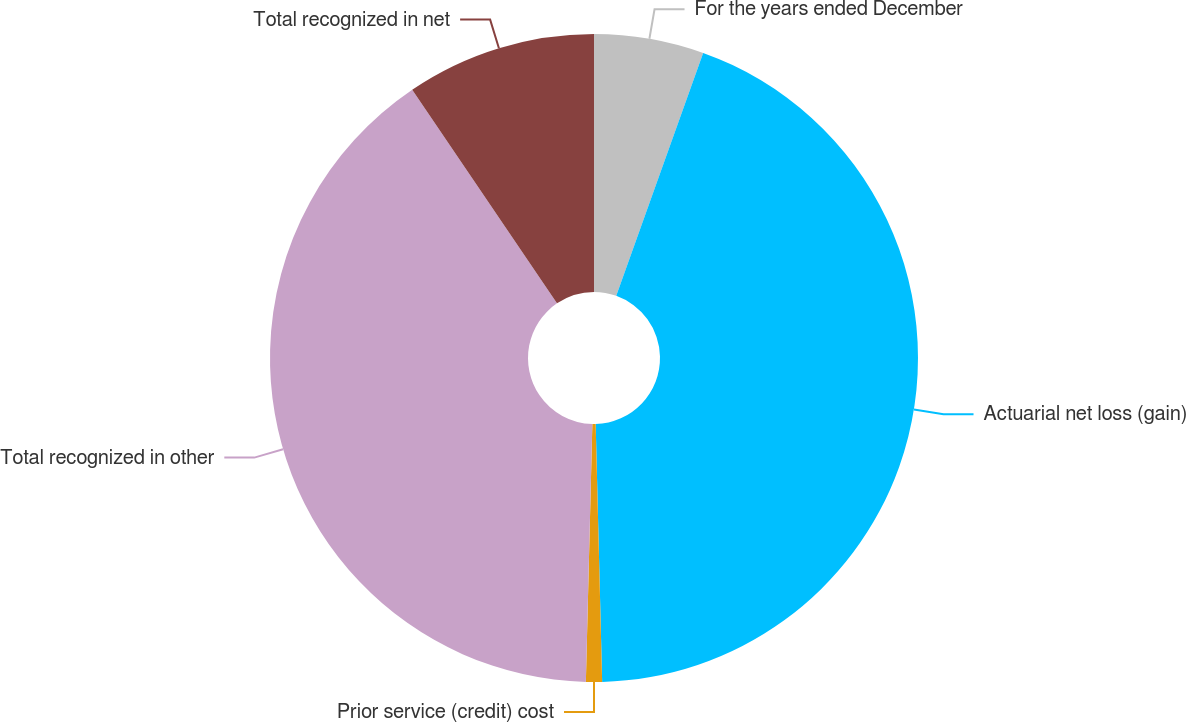Convert chart to OTSL. <chart><loc_0><loc_0><loc_500><loc_500><pie_chart><fcel>For the years ended December<fcel>Actuarial net loss (gain)<fcel>Prior service (credit) cost<fcel>Total recognized in other<fcel>Total recognized in net<nl><fcel>5.47%<fcel>44.13%<fcel>0.8%<fcel>40.12%<fcel>9.48%<nl></chart> 